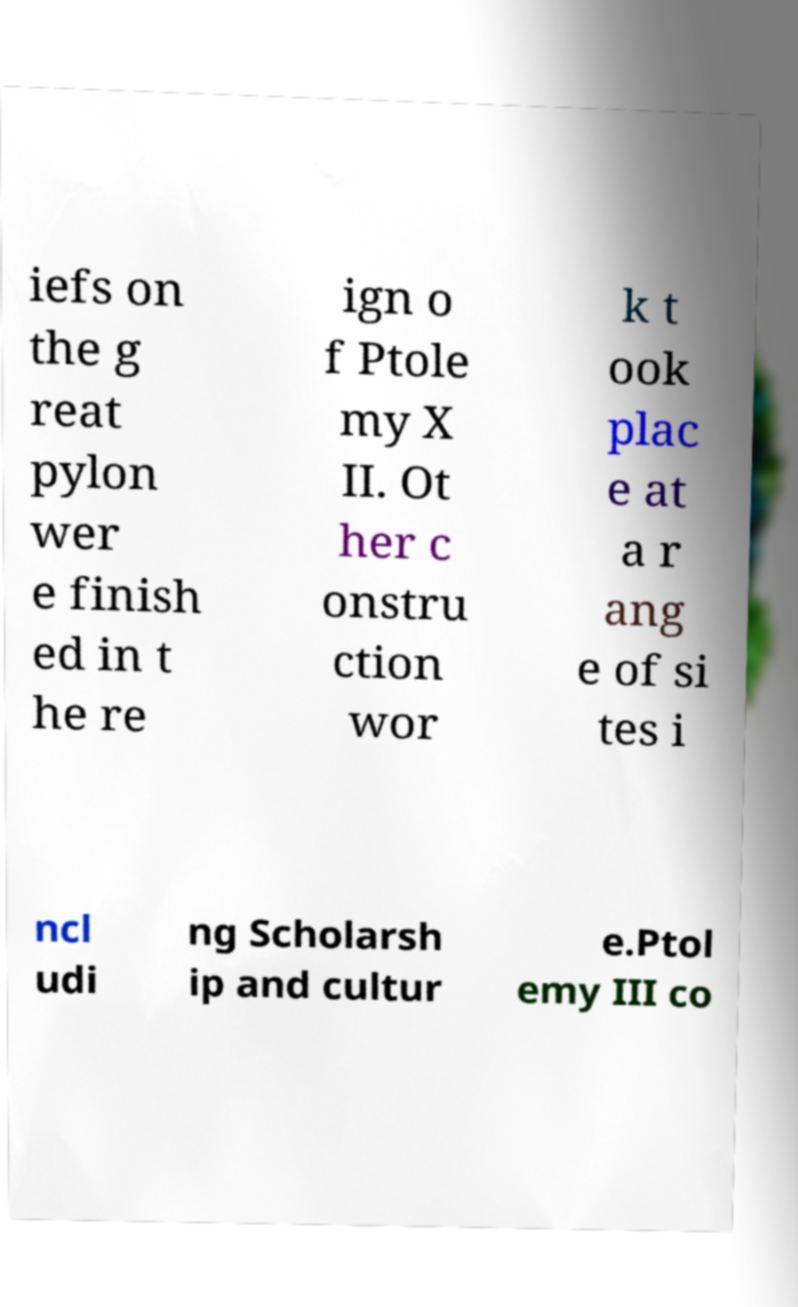What messages or text are displayed in this image? I need them in a readable, typed format. iefs on the g reat pylon wer e finish ed in t he re ign o f Ptole my X II. Ot her c onstru ction wor k t ook plac e at a r ang e of si tes i ncl udi ng Scholarsh ip and cultur e.Ptol emy III co 